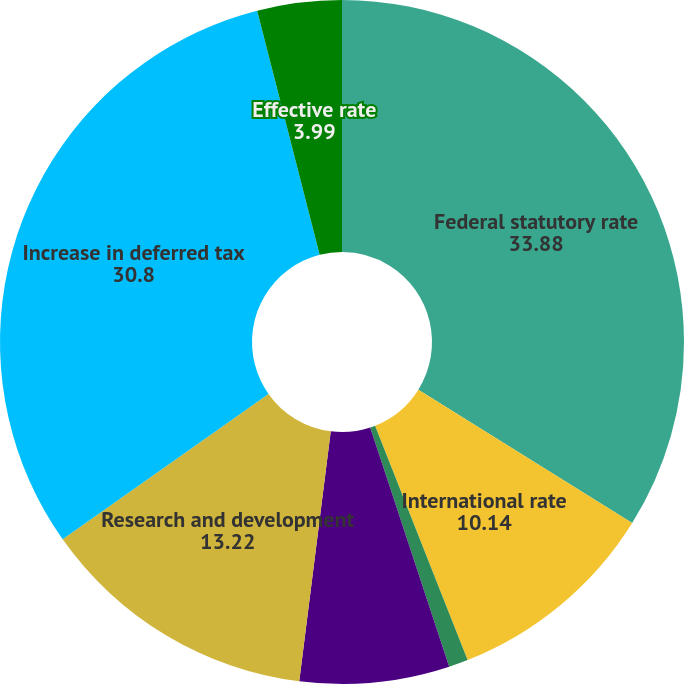<chart> <loc_0><loc_0><loc_500><loc_500><pie_chart><fcel>Federal statutory rate<fcel>International rate<fcel>Permanent difference<fcel>State tax benefit net of<fcel>Research and development<fcel>Increase in deferred tax<fcel>Effective rate<nl><fcel>33.88%<fcel>10.14%<fcel>0.91%<fcel>7.07%<fcel>13.22%<fcel>30.8%<fcel>3.99%<nl></chart> 